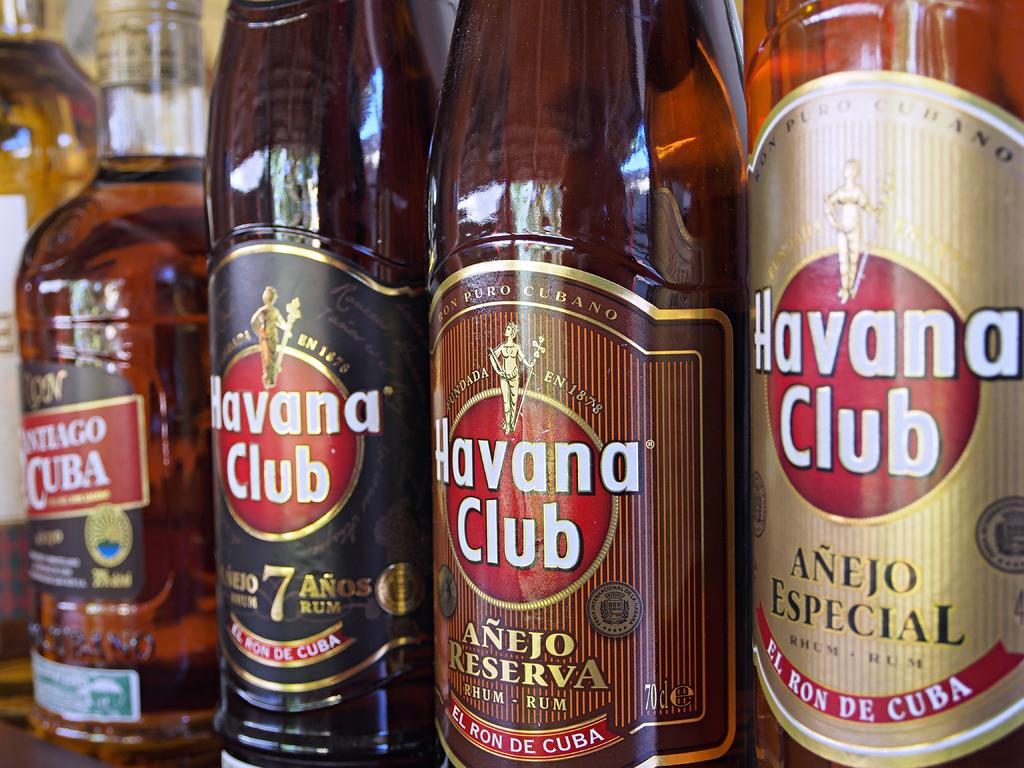<image>
Provide a brief description of the given image. Several bottles of Havana Club beer lined up in a row, 